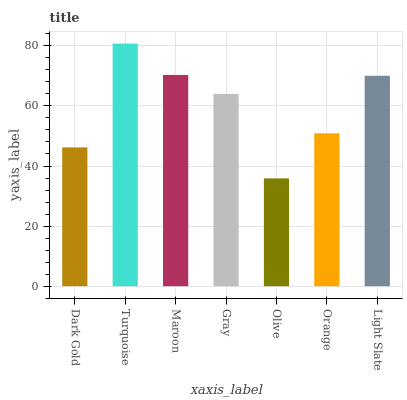Is Maroon the minimum?
Answer yes or no. No. Is Maroon the maximum?
Answer yes or no. No. Is Turquoise greater than Maroon?
Answer yes or no. Yes. Is Maroon less than Turquoise?
Answer yes or no. Yes. Is Maroon greater than Turquoise?
Answer yes or no. No. Is Turquoise less than Maroon?
Answer yes or no. No. Is Gray the high median?
Answer yes or no. Yes. Is Gray the low median?
Answer yes or no. Yes. Is Olive the high median?
Answer yes or no. No. Is Light Slate the low median?
Answer yes or no. No. 